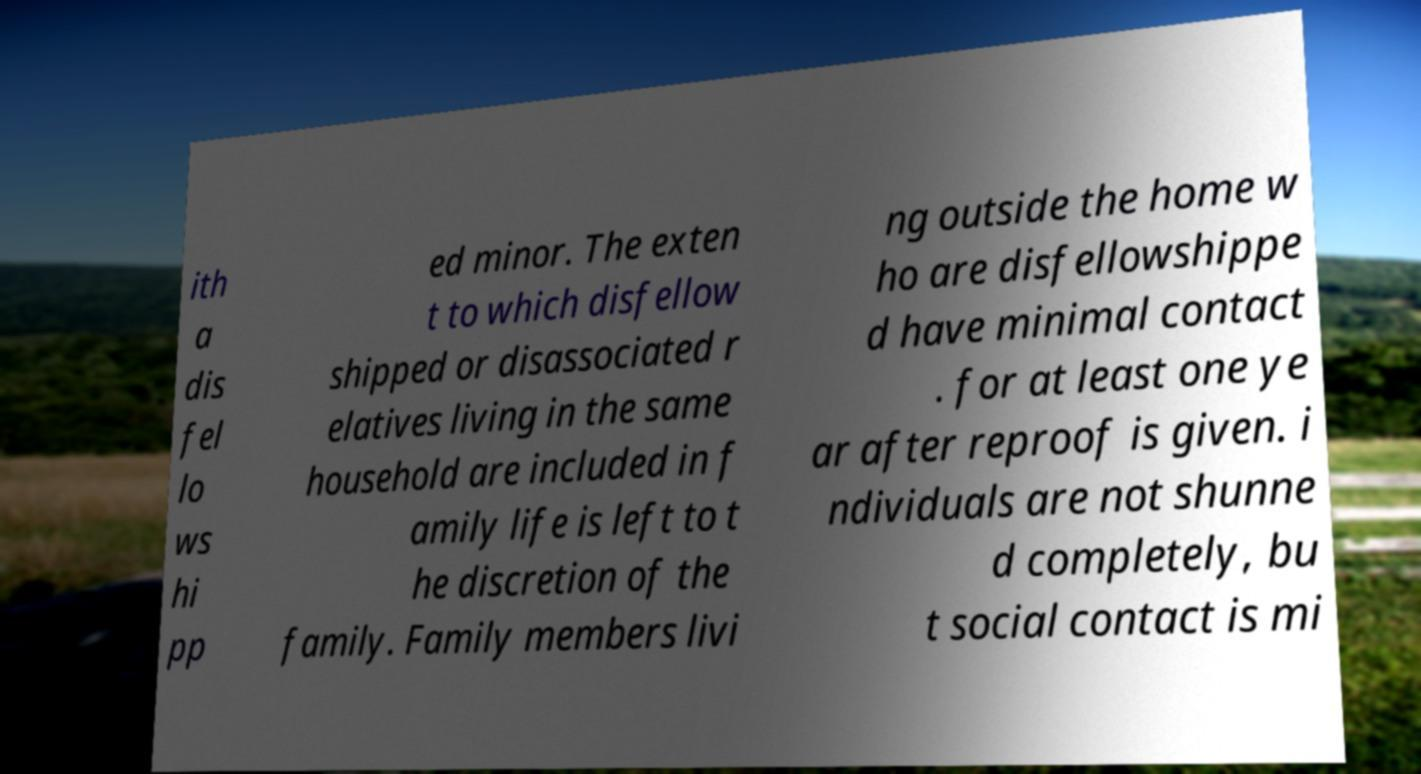What messages or text are displayed in this image? I need them in a readable, typed format. ith a dis fel lo ws hi pp ed minor. The exten t to which disfellow shipped or disassociated r elatives living in the same household are included in f amily life is left to t he discretion of the family. Family members livi ng outside the home w ho are disfellowshippe d have minimal contact . for at least one ye ar after reproof is given. i ndividuals are not shunne d completely, bu t social contact is mi 